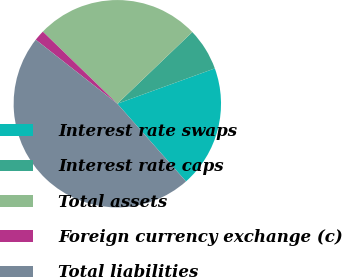<chart> <loc_0><loc_0><loc_500><loc_500><pie_chart><fcel>Interest rate swaps<fcel>Interest rate caps<fcel>Total assets<fcel>Foreign currency exchange (c)<fcel>Total liabilities<nl><fcel>19.01%<fcel>6.61%<fcel>25.62%<fcel>1.65%<fcel>47.11%<nl></chart> 